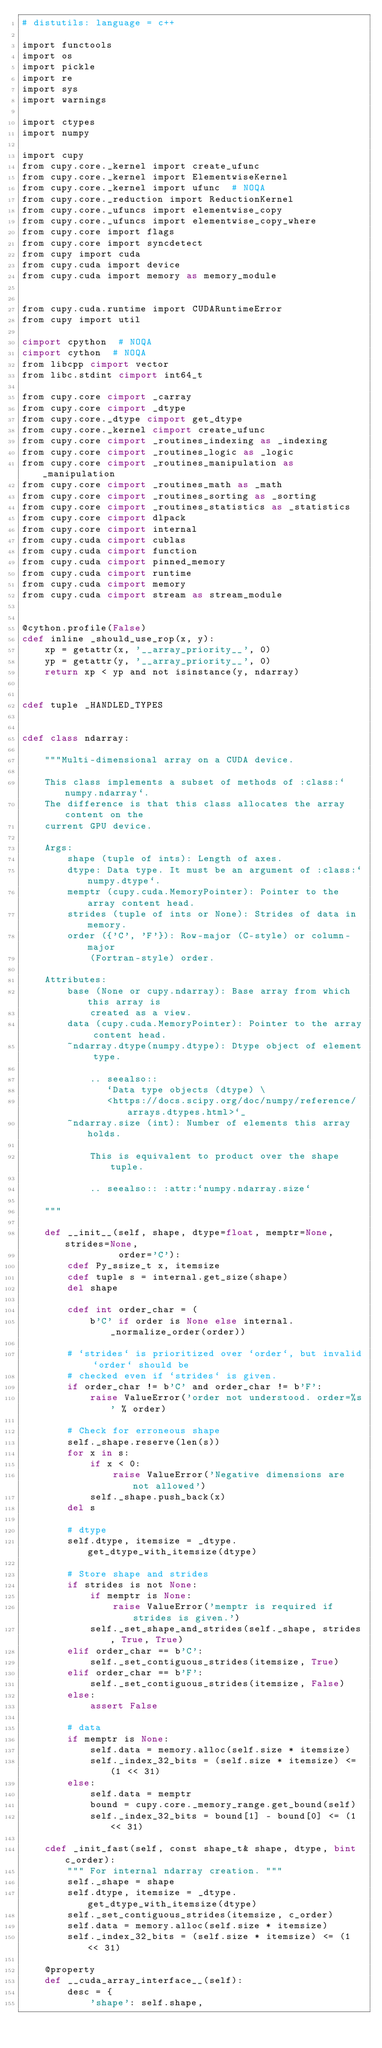<code> <loc_0><loc_0><loc_500><loc_500><_Cython_># distutils: language = c++

import functools
import os
import pickle
import re
import sys
import warnings

import ctypes
import numpy

import cupy
from cupy.core._kernel import create_ufunc
from cupy.core._kernel import ElementwiseKernel
from cupy.core._kernel import ufunc  # NOQA
from cupy.core._reduction import ReductionKernel
from cupy.core._ufuncs import elementwise_copy
from cupy.core._ufuncs import elementwise_copy_where
from cupy.core import flags
from cupy.core import syncdetect
from cupy import cuda
from cupy.cuda import device
from cupy.cuda import memory as memory_module


from cupy.cuda.runtime import CUDARuntimeError
from cupy import util

cimport cpython  # NOQA
cimport cython  # NOQA
from libcpp cimport vector
from libc.stdint cimport int64_t

from cupy.core cimport _carray
from cupy.core cimport _dtype
from cupy.core._dtype cimport get_dtype
from cupy.core._kernel cimport create_ufunc
from cupy.core cimport _routines_indexing as _indexing
from cupy.core cimport _routines_logic as _logic
from cupy.core cimport _routines_manipulation as _manipulation
from cupy.core cimport _routines_math as _math
from cupy.core cimport _routines_sorting as _sorting
from cupy.core cimport _routines_statistics as _statistics
from cupy.core cimport dlpack
from cupy.core cimport internal
from cupy.cuda cimport cublas
from cupy.cuda cimport function
from cupy.cuda cimport pinned_memory
from cupy.cuda cimport runtime
from cupy.cuda cimport memory
from cupy.cuda cimport stream as stream_module


@cython.profile(False)
cdef inline _should_use_rop(x, y):
    xp = getattr(x, '__array_priority__', 0)
    yp = getattr(y, '__array_priority__', 0)
    return xp < yp and not isinstance(y, ndarray)


cdef tuple _HANDLED_TYPES


cdef class ndarray:

    """Multi-dimensional array on a CUDA device.

    This class implements a subset of methods of :class:`numpy.ndarray`.
    The difference is that this class allocates the array content on the
    current GPU device.

    Args:
        shape (tuple of ints): Length of axes.
        dtype: Data type. It must be an argument of :class:`numpy.dtype`.
        memptr (cupy.cuda.MemoryPointer): Pointer to the array content head.
        strides (tuple of ints or None): Strides of data in memory.
        order ({'C', 'F'}): Row-major (C-style) or column-major
            (Fortran-style) order.

    Attributes:
        base (None or cupy.ndarray): Base array from which this array is
            created as a view.
        data (cupy.cuda.MemoryPointer): Pointer to the array content head.
        ~ndarray.dtype(numpy.dtype): Dtype object of element type.

            .. seealso::
               `Data type objects (dtype) \
               <https://docs.scipy.org/doc/numpy/reference/arrays.dtypes.html>`_
        ~ndarray.size (int): Number of elements this array holds.

            This is equivalent to product over the shape tuple.

            .. seealso:: :attr:`numpy.ndarray.size`

    """

    def __init__(self, shape, dtype=float, memptr=None, strides=None,
                 order='C'):
        cdef Py_ssize_t x, itemsize
        cdef tuple s = internal.get_size(shape)
        del shape

        cdef int order_char = (
            b'C' if order is None else internal._normalize_order(order))

        # `strides` is prioritized over `order`, but invalid `order` should be
        # checked even if `strides` is given.
        if order_char != b'C' and order_char != b'F':
            raise ValueError('order not understood. order=%s' % order)

        # Check for erroneous shape
        self._shape.reserve(len(s))
        for x in s:
            if x < 0:
                raise ValueError('Negative dimensions are not allowed')
            self._shape.push_back(x)
        del s

        # dtype
        self.dtype, itemsize = _dtype.get_dtype_with_itemsize(dtype)

        # Store shape and strides
        if strides is not None:
            if memptr is None:
                raise ValueError('memptr is required if strides is given.')
            self._set_shape_and_strides(self._shape, strides, True, True)
        elif order_char == b'C':
            self._set_contiguous_strides(itemsize, True)
        elif order_char == b'F':
            self._set_contiguous_strides(itemsize, False)
        else:
            assert False

        # data
        if memptr is None:
            self.data = memory.alloc(self.size * itemsize)
            self._index_32_bits = (self.size * itemsize) <= (1 << 31)
        else:
            self.data = memptr
            bound = cupy.core._memory_range.get_bound(self)
            self._index_32_bits = bound[1] - bound[0] <= (1 << 31)

    cdef _init_fast(self, const shape_t& shape, dtype, bint c_order):
        """ For internal ndarray creation. """
        self._shape = shape
        self.dtype, itemsize = _dtype.get_dtype_with_itemsize(dtype)
        self._set_contiguous_strides(itemsize, c_order)
        self.data = memory.alloc(self.size * itemsize)
        self._index_32_bits = (self.size * itemsize) <= (1 << 31)

    @property
    def __cuda_array_interface__(self):
        desc = {
            'shape': self.shape,</code> 